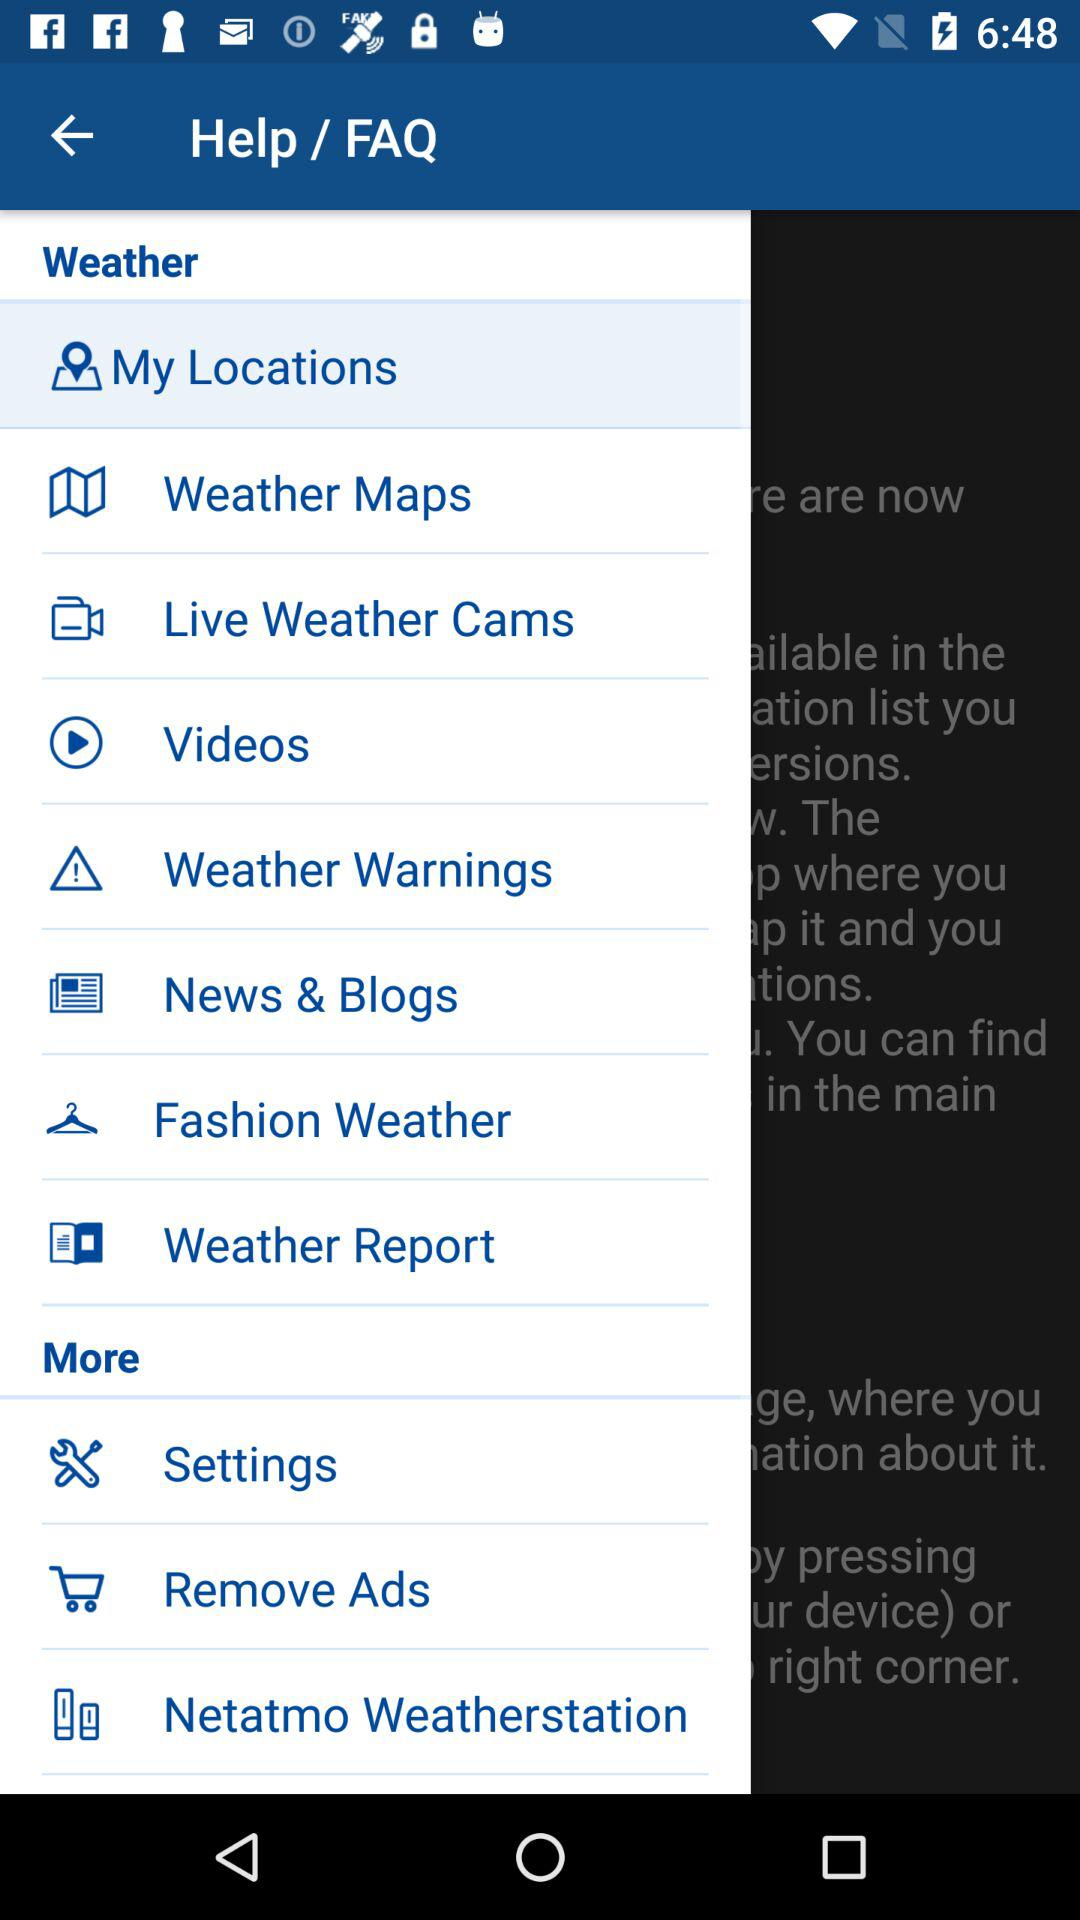Which item has been selected? The item that has been selected is "My Locations". 